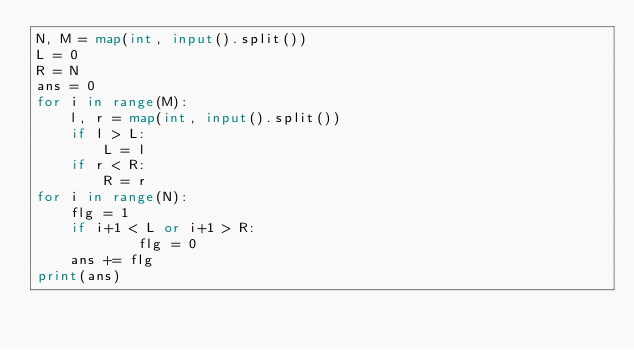Convert code to text. <code><loc_0><loc_0><loc_500><loc_500><_Python_>N, M = map(int, input().split())
L = 0
R = N
ans = 0
for i in range(M):
    l, r = map(int, input().split())
    if l > L:
        L = l
    if r < R:
        R = r
for i in range(N):
    flg = 1
    if i+1 < L or i+1 > R:
            flg = 0
    ans += flg
print(ans)</code> 